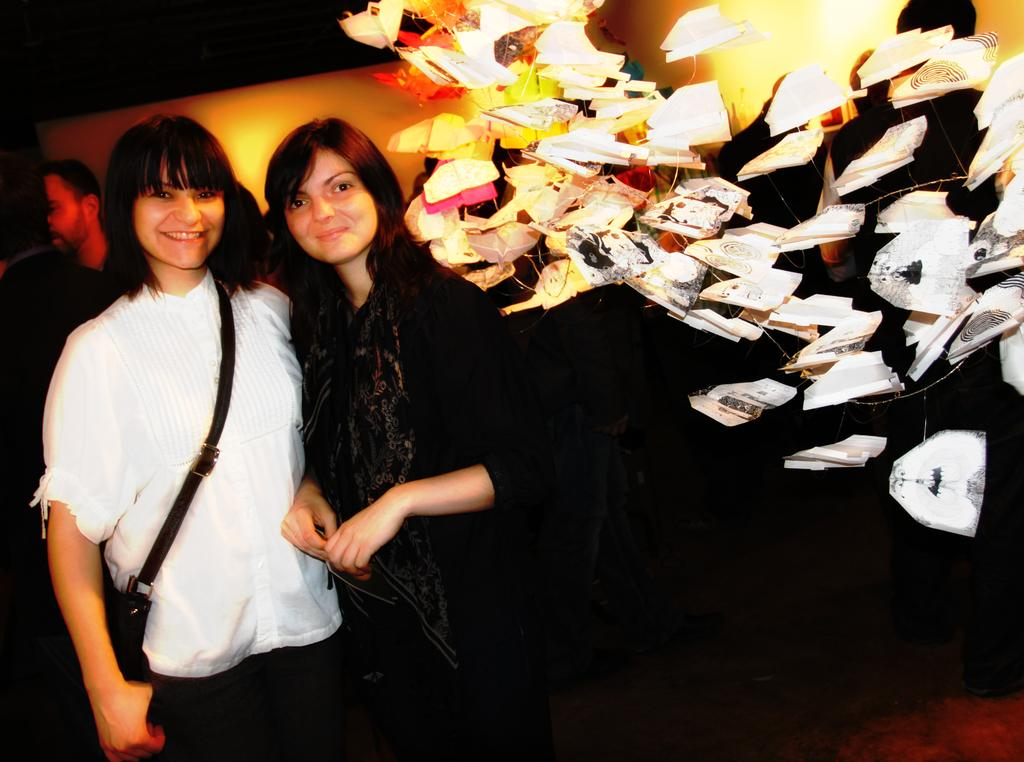What is the main subject of the image? The main subject of the image is a group of people. What colors are the people wearing? The people are wearing white and black color dresses. What can be seen to the right of the group? There are objects to the right of the group. What colors are present in the background of the image? The background of the image is black and yellow in color. What type of cord is being used by the people in the image? There is no cord visible in the image; the people are wearing white and black color dresses. What is the pail being used for in the image? There is no pail present in the image; the main subjects are a group of people wearing white and black color dresses. 